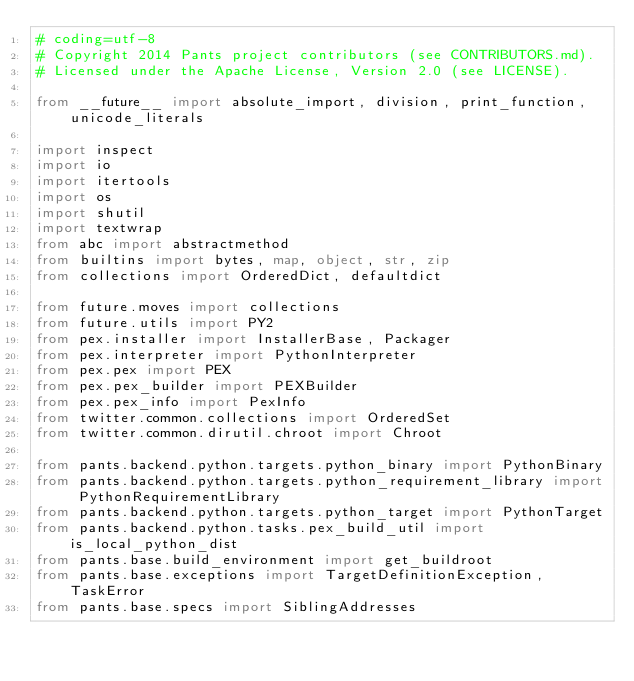<code> <loc_0><loc_0><loc_500><loc_500><_Python_># coding=utf-8
# Copyright 2014 Pants project contributors (see CONTRIBUTORS.md).
# Licensed under the Apache License, Version 2.0 (see LICENSE).

from __future__ import absolute_import, division, print_function, unicode_literals

import inspect
import io
import itertools
import os
import shutil
import textwrap
from abc import abstractmethod
from builtins import bytes, map, object, str, zip
from collections import OrderedDict, defaultdict

from future.moves import collections
from future.utils import PY2
from pex.installer import InstallerBase, Packager
from pex.interpreter import PythonInterpreter
from pex.pex import PEX
from pex.pex_builder import PEXBuilder
from pex.pex_info import PexInfo
from twitter.common.collections import OrderedSet
from twitter.common.dirutil.chroot import Chroot

from pants.backend.python.targets.python_binary import PythonBinary
from pants.backend.python.targets.python_requirement_library import PythonRequirementLibrary
from pants.backend.python.targets.python_target import PythonTarget
from pants.backend.python.tasks.pex_build_util import is_local_python_dist
from pants.base.build_environment import get_buildroot
from pants.base.exceptions import TargetDefinitionException, TaskError
from pants.base.specs import SiblingAddresses</code> 